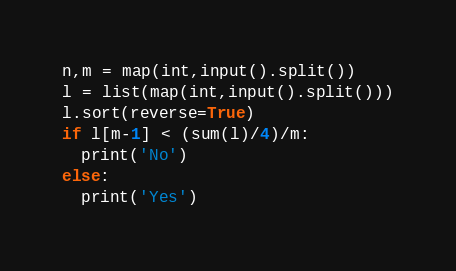Convert code to text. <code><loc_0><loc_0><loc_500><loc_500><_Python_>n,m = map(int,input().split())
l = list(map(int,input().split()))
l.sort(reverse=True)
if l[m-1] < (sum(l)/4)/m:
  print('No')
else:
  print('Yes')</code> 